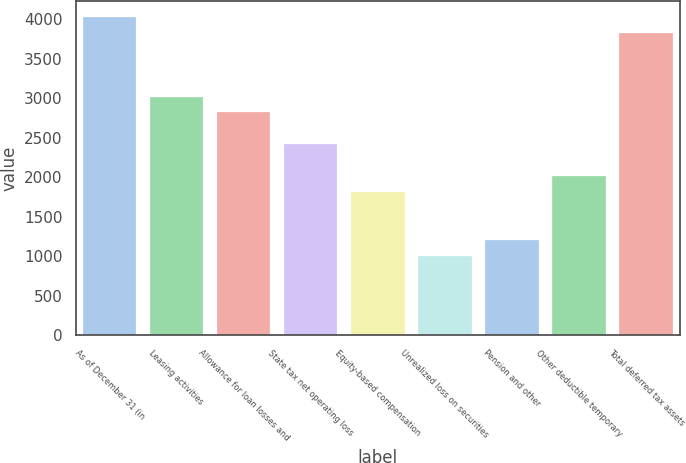Convert chart to OTSL. <chart><loc_0><loc_0><loc_500><loc_500><bar_chart><fcel>As of December 31 (in<fcel>Leasing activities<fcel>Allowance for loan losses and<fcel>State tax net operating loss<fcel>Equity-based compensation<fcel>Unrealized loss on securities<fcel>Pension and other<fcel>Other deductible temporary<fcel>Total deferred tax assets<nl><fcel>4028.1<fcel>3021.55<fcel>2820.24<fcel>2417.62<fcel>1813.69<fcel>1008.45<fcel>1209.76<fcel>2015<fcel>3826.79<nl></chart> 